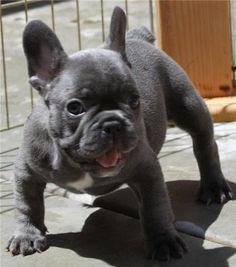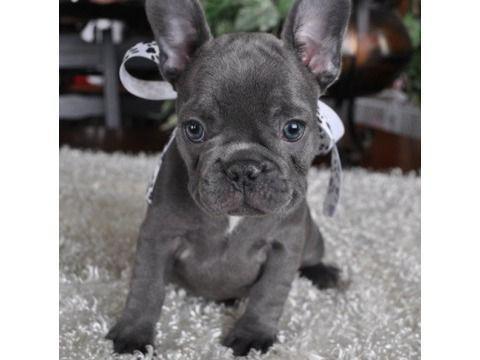The first image is the image on the left, the second image is the image on the right. Assess this claim about the two images: "The dog in the right image is wearing a human-like accessory.". Correct or not? Answer yes or no. Yes. The first image is the image on the left, the second image is the image on the right. Evaluate the accuracy of this statement regarding the images: "The lefthand image contains exactly one dog, which is standing on all fours, and the right image shows one sitting dog.". Is it true? Answer yes or no. Yes. 